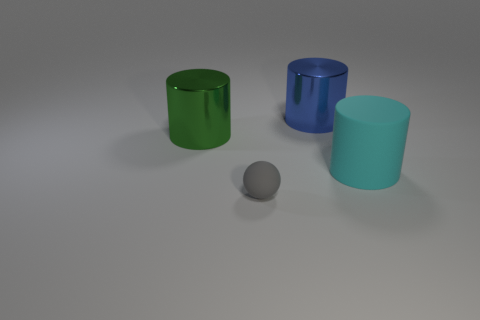Are there any tiny cubes that have the same color as the large matte thing?
Offer a very short reply. No. What number of cyan things are rubber things or tiny rubber objects?
Offer a terse response. 1. What number of other things are the same size as the gray rubber ball?
Your answer should be very brief. 0. How many tiny things are yellow matte cylinders or spheres?
Offer a very short reply. 1. Does the cyan matte thing have the same size as the gray matte sphere that is left of the blue metallic object?
Give a very brief answer. No. How many other objects are the same shape as the blue object?
Keep it short and to the point. 2. There is a object that is the same material as the tiny ball; what is its shape?
Offer a terse response. Cylinder. Is there a large brown thing?
Give a very brief answer. No. Are there fewer cyan objects to the left of the large green metallic thing than tiny gray matte things in front of the small gray matte ball?
Offer a very short reply. No. What shape is the rubber object in front of the big cyan matte thing?
Offer a terse response. Sphere. 